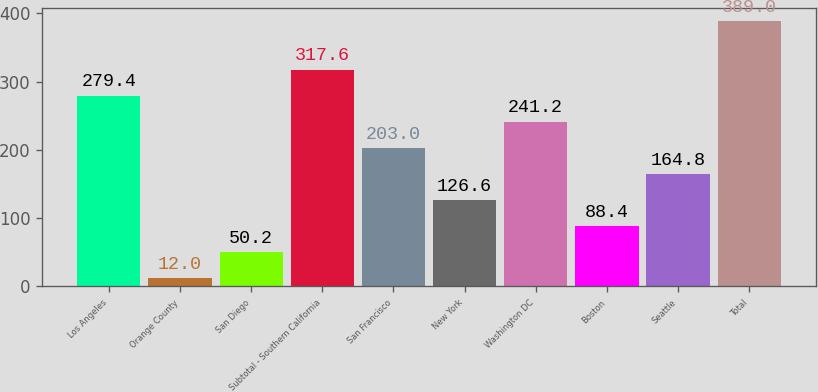Convert chart. <chart><loc_0><loc_0><loc_500><loc_500><bar_chart><fcel>Los Angeles<fcel>Orange County<fcel>San Diego<fcel>Subtotal - Southern California<fcel>San Francisco<fcel>New York<fcel>Washington DC<fcel>Boston<fcel>Seattle<fcel>Total<nl><fcel>279.4<fcel>12<fcel>50.2<fcel>317.6<fcel>203<fcel>126.6<fcel>241.2<fcel>88.4<fcel>164.8<fcel>389<nl></chart> 